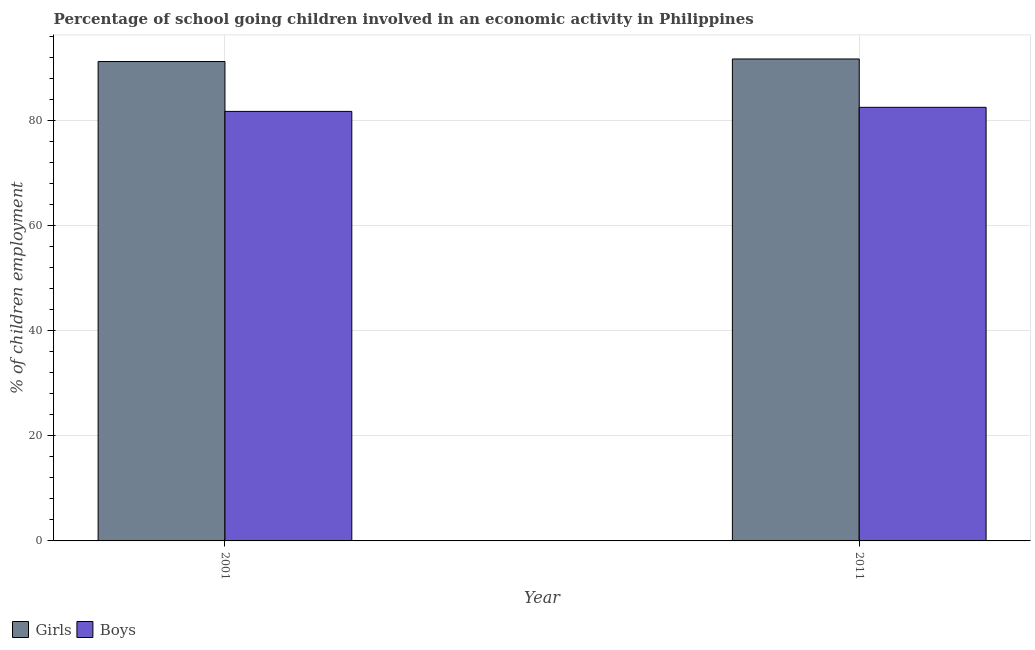How many groups of bars are there?
Offer a very short reply. 2. Are the number of bars per tick equal to the number of legend labels?
Your answer should be compact. Yes. What is the percentage of school going girls in 2011?
Ensure brevity in your answer.  91.7. Across all years, what is the maximum percentage of school going boys?
Offer a very short reply. 82.5. Across all years, what is the minimum percentage of school going boys?
Make the answer very short. 81.73. In which year was the percentage of school going boys maximum?
Ensure brevity in your answer.  2011. What is the total percentage of school going boys in the graph?
Provide a succinct answer. 164.23. What is the difference between the percentage of school going boys in 2001 and that in 2011?
Ensure brevity in your answer.  -0.77. What is the difference between the percentage of school going boys in 2011 and the percentage of school going girls in 2001?
Ensure brevity in your answer.  0.77. What is the average percentage of school going boys per year?
Keep it short and to the point. 82.11. In the year 2001, what is the difference between the percentage of school going girls and percentage of school going boys?
Ensure brevity in your answer.  0. What is the ratio of the percentage of school going girls in 2001 to that in 2011?
Your answer should be compact. 0.99. Is the percentage of school going girls in 2001 less than that in 2011?
Provide a short and direct response. Yes. What does the 2nd bar from the left in 2011 represents?
Provide a short and direct response. Boys. What does the 1st bar from the right in 2011 represents?
Keep it short and to the point. Boys. Are all the bars in the graph horizontal?
Ensure brevity in your answer.  No. Are the values on the major ticks of Y-axis written in scientific E-notation?
Offer a very short reply. No. Does the graph contain any zero values?
Offer a very short reply. No. Where does the legend appear in the graph?
Provide a short and direct response. Bottom left. How many legend labels are there?
Offer a terse response. 2. What is the title of the graph?
Provide a succinct answer. Percentage of school going children involved in an economic activity in Philippines. Does "Crop" appear as one of the legend labels in the graph?
Give a very brief answer. No. What is the label or title of the Y-axis?
Make the answer very short. % of children employment. What is the % of children employment in Girls in 2001?
Your answer should be very brief. 91.21. What is the % of children employment of Boys in 2001?
Offer a very short reply. 81.73. What is the % of children employment in Girls in 2011?
Offer a very short reply. 91.7. What is the % of children employment of Boys in 2011?
Your answer should be compact. 82.5. Across all years, what is the maximum % of children employment of Girls?
Make the answer very short. 91.7. Across all years, what is the maximum % of children employment in Boys?
Your answer should be very brief. 82.5. Across all years, what is the minimum % of children employment of Girls?
Provide a short and direct response. 91.21. Across all years, what is the minimum % of children employment in Boys?
Your answer should be very brief. 81.73. What is the total % of children employment in Girls in the graph?
Your answer should be very brief. 182.91. What is the total % of children employment of Boys in the graph?
Keep it short and to the point. 164.23. What is the difference between the % of children employment of Girls in 2001 and that in 2011?
Your answer should be very brief. -0.49. What is the difference between the % of children employment of Boys in 2001 and that in 2011?
Make the answer very short. -0.77. What is the difference between the % of children employment in Girls in 2001 and the % of children employment in Boys in 2011?
Your answer should be very brief. 8.71. What is the average % of children employment in Girls per year?
Keep it short and to the point. 91.46. What is the average % of children employment of Boys per year?
Offer a terse response. 82.11. In the year 2001, what is the difference between the % of children employment of Girls and % of children employment of Boys?
Offer a very short reply. 9.49. In the year 2011, what is the difference between the % of children employment in Girls and % of children employment in Boys?
Keep it short and to the point. 9.2. What is the ratio of the % of children employment in Boys in 2001 to that in 2011?
Make the answer very short. 0.99. What is the difference between the highest and the second highest % of children employment of Girls?
Your answer should be very brief. 0.49. What is the difference between the highest and the second highest % of children employment of Boys?
Your response must be concise. 0.77. What is the difference between the highest and the lowest % of children employment of Girls?
Ensure brevity in your answer.  0.49. What is the difference between the highest and the lowest % of children employment of Boys?
Ensure brevity in your answer.  0.77. 